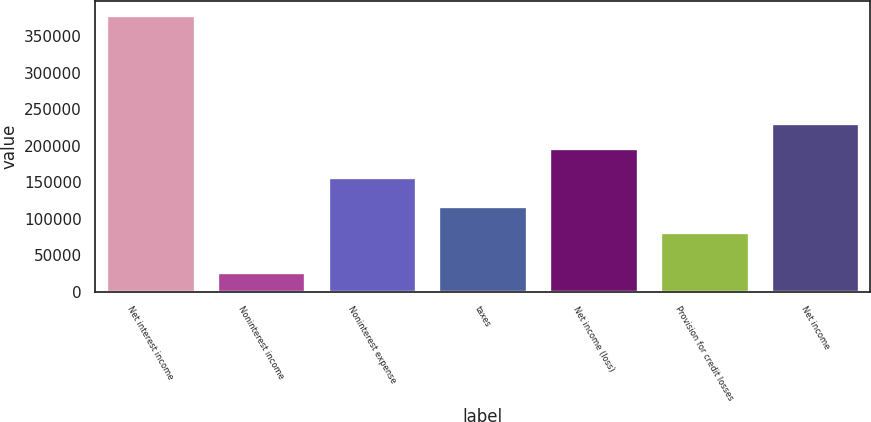<chart> <loc_0><loc_0><loc_500><loc_500><bar_chart><fcel>Net interest income<fcel>Noninterest income<fcel>Noninterest expense<fcel>taxes<fcel>Net income (loss)<fcel>Provision for credit losses<fcel>Net income<nl><fcel>379363<fcel>26628<fcel>156715<fcel>117542<fcel>196377<fcel>82269<fcel>231650<nl></chart> 